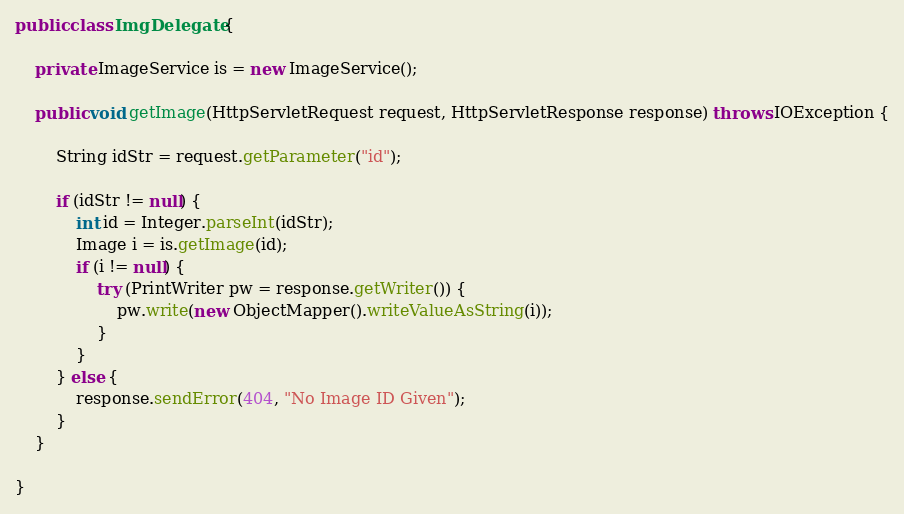<code> <loc_0><loc_0><loc_500><loc_500><_Java_>public class ImgDelegate {

	private ImageService is = new ImageService();

	public void getImage(HttpServletRequest request, HttpServletResponse response) throws IOException {

		String idStr = request.getParameter("id");

		if (idStr != null) {
			int id = Integer.parseInt(idStr);
			Image i = is.getImage(id);
			if (i != null) {
				try (PrintWriter pw = response.getWriter()) {
					pw.write(new ObjectMapper().writeValueAsString(i));
				}
			}
		} else {
			response.sendError(404, "No Image ID Given");
		}
	}

}
</code> 